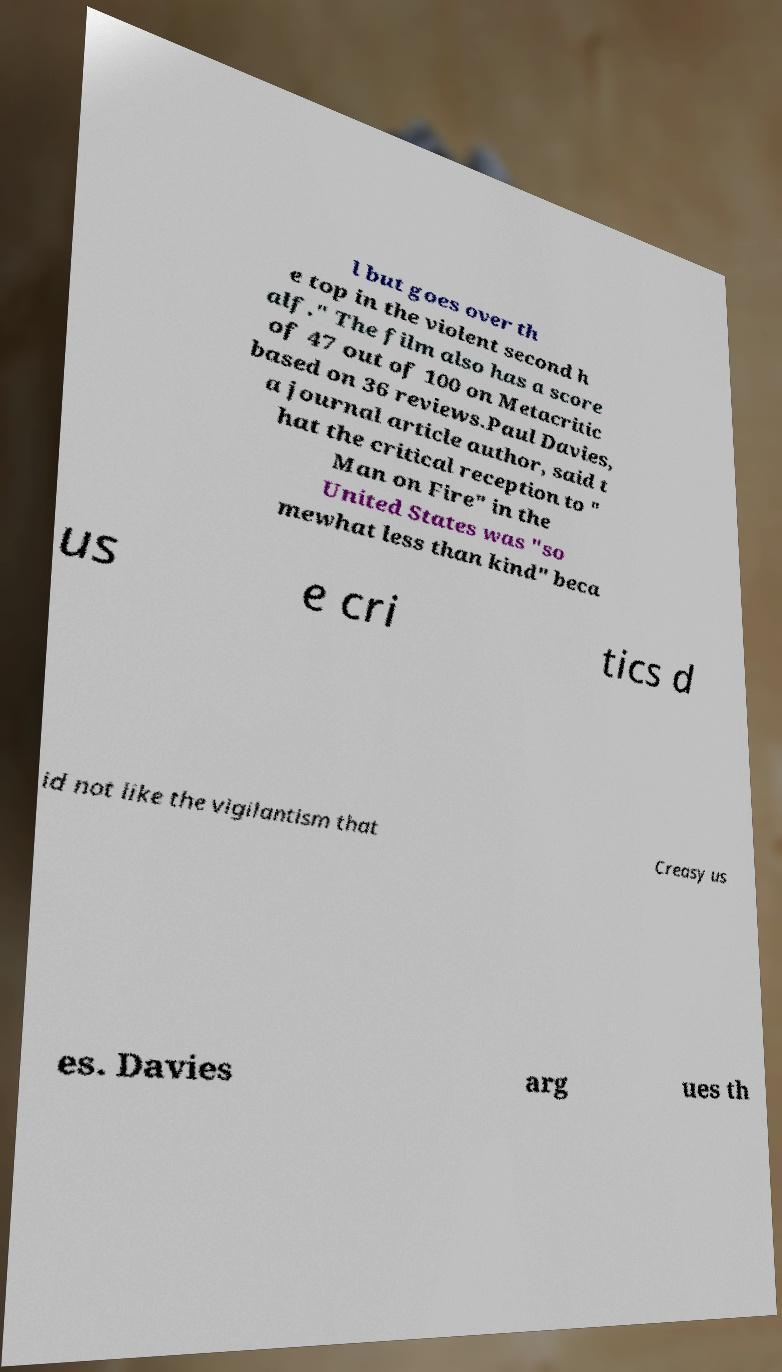Please read and relay the text visible in this image. What does it say? l but goes over th e top in the violent second h alf." The film also has a score of 47 out of 100 on Metacritic based on 36 reviews.Paul Davies, a journal article author, said t hat the critical reception to " Man on Fire" in the United States was "so mewhat less than kind" beca us e cri tics d id not like the vigilantism that Creasy us es. Davies arg ues th 